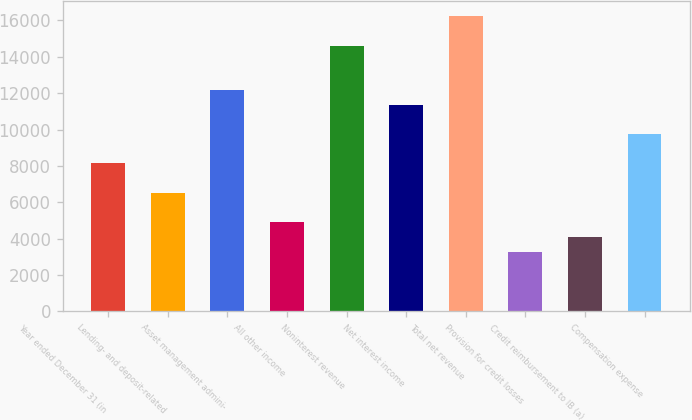Convert chart. <chart><loc_0><loc_0><loc_500><loc_500><bar_chart><fcel>Year ended December 31 (in<fcel>Lending- and deposit-related<fcel>Asset management admini-<fcel>All other income<fcel>Noninterest revenue<fcel>Net interest income<fcel>Total net revenue<fcel>Provision for credit losses<fcel>Credit reimbursement to IB (a)<fcel>Compensation expense<nl><fcel>8134<fcel>6513.8<fcel>12184.5<fcel>4893.6<fcel>14614.8<fcel>11374.4<fcel>16235<fcel>3273.4<fcel>4083.5<fcel>9754.2<nl></chart> 